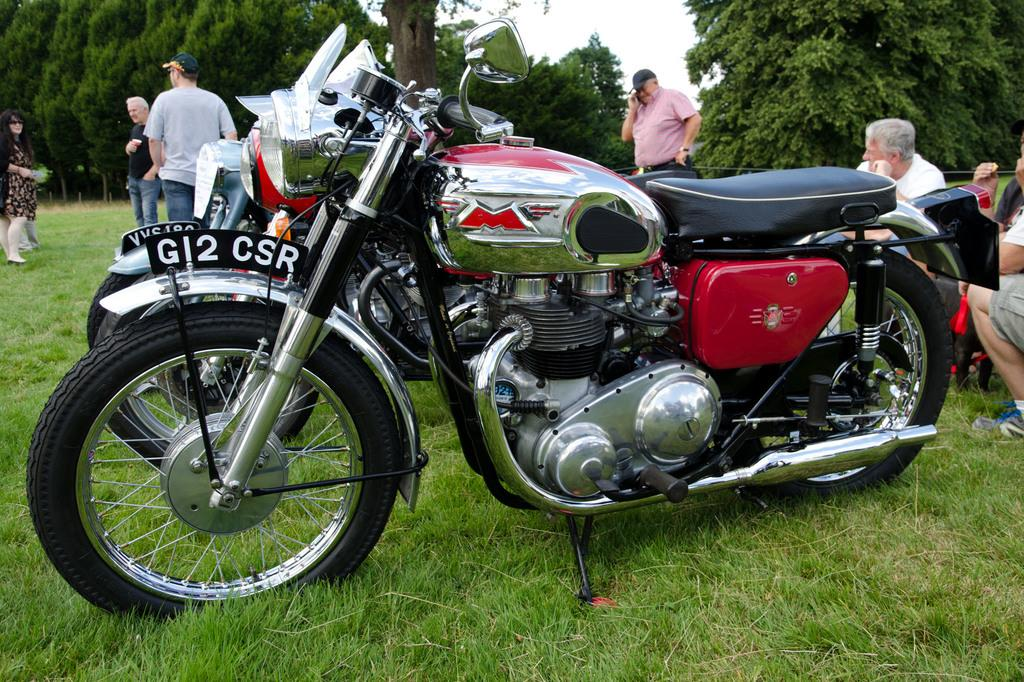What type of vehicles are on the grass in the image? There are motorcycles on the grass in the image. What can be seen near the motorcycles? There is a group of people near the motorcycles. What is visible in the background of the image? There are trees in the background of the image. What is the value of the volcano in the image? There is no volcano present in the image, so it is not possible to determine its value. 